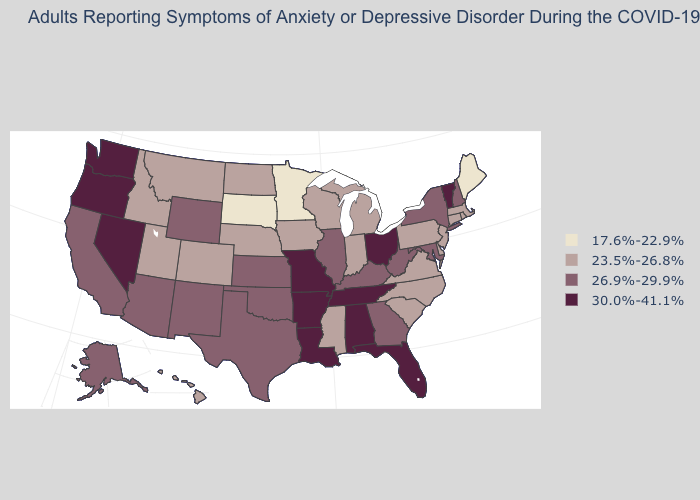Name the states that have a value in the range 23.5%-26.8%?
Give a very brief answer. Colorado, Connecticut, Delaware, Hawaii, Idaho, Indiana, Iowa, Massachusetts, Michigan, Mississippi, Montana, Nebraska, New Jersey, North Carolina, North Dakota, Pennsylvania, Rhode Island, South Carolina, Utah, Virginia, Wisconsin. Which states have the highest value in the USA?
Write a very short answer. Alabama, Arkansas, Florida, Louisiana, Missouri, Nevada, Ohio, Oregon, Tennessee, Vermont, Washington. What is the value of Rhode Island?
Be succinct. 23.5%-26.8%. Among the states that border Oklahoma , does New Mexico have the highest value?
Quick response, please. No. Among the states that border New Hampshire , which have the lowest value?
Give a very brief answer. Maine. Does Massachusetts have a lower value than Nebraska?
Concise answer only. No. Name the states that have a value in the range 30.0%-41.1%?
Be succinct. Alabama, Arkansas, Florida, Louisiana, Missouri, Nevada, Ohio, Oregon, Tennessee, Vermont, Washington. Which states have the lowest value in the USA?
Short answer required. Maine, Minnesota, South Dakota. What is the lowest value in the USA?
Be succinct. 17.6%-22.9%. Does New Jersey have the highest value in the Northeast?
Keep it brief. No. Does the map have missing data?
Give a very brief answer. No. Among the states that border Vermont , does New Hampshire have the lowest value?
Quick response, please. No. Does Florida have the lowest value in the USA?
Short answer required. No. Is the legend a continuous bar?
Be succinct. No. Name the states that have a value in the range 17.6%-22.9%?
Give a very brief answer. Maine, Minnesota, South Dakota. 